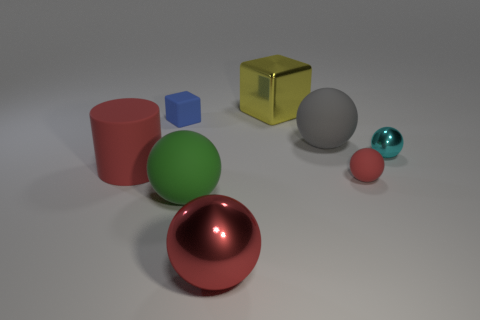How many objects are big things that are left of the large metal ball or large spheres?
Ensure brevity in your answer.  4. Are the cyan thing and the large cube made of the same material?
Ensure brevity in your answer.  Yes. There is a blue rubber thing that is the same shape as the large yellow metal object; what size is it?
Offer a very short reply. Small. There is a tiny matte thing in front of the big gray rubber sphere; does it have the same shape as the large red object to the right of the cylinder?
Provide a succinct answer. Yes. Do the red metallic thing and the red sphere that is to the right of the large yellow metallic block have the same size?
Offer a terse response. No. How many other things are there of the same material as the cylinder?
Provide a short and direct response. 4. Is there anything else that is the same shape as the yellow object?
Your answer should be very brief. Yes. What color is the big sphere behind the tiny matte object that is in front of the tiny rubber thing behind the small metallic sphere?
Make the answer very short. Gray. There is a big object that is behind the tiny cyan object and in front of the yellow metallic object; what shape is it?
Provide a succinct answer. Sphere. Is there any other thing that has the same size as the red metal object?
Provide a short and direct response. Yes. 